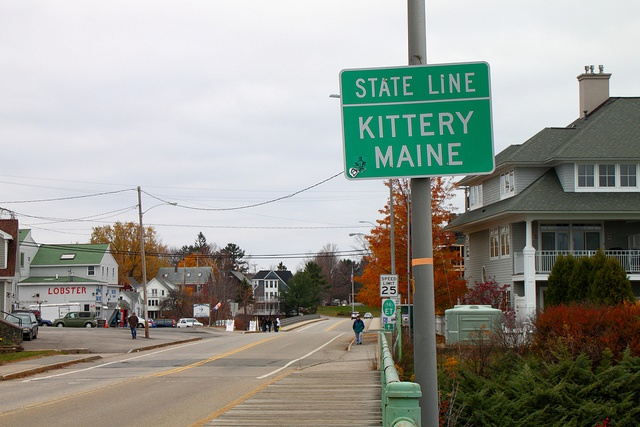Describe the objects in this image and their specific colors. I can see car in white, black, gray, darkgreen, and darkgray tones, car in white, darkgray, gray, and black tones, people in white, black, gray, darkblue, and blue tones, car in white, darkgray, lightgray, gray, and maroon tones, and people in white, black, gray, maroon, and navy tones in this image. 